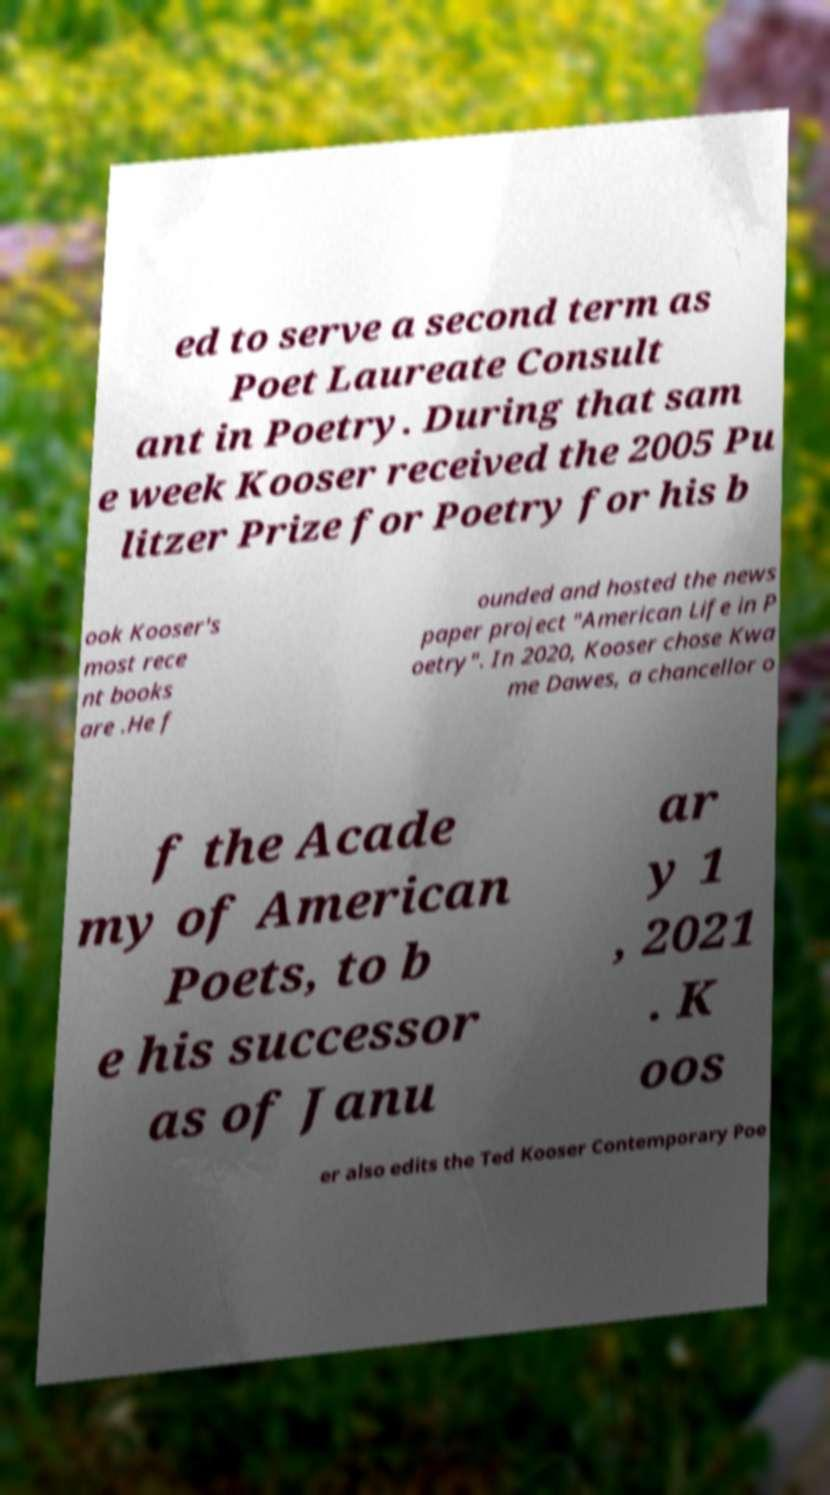Can you accurately transcribe the text from the provided image for me? ed to serve a second term as Poet Laureate Consult ant in Poetry. During that sam e week Kooser received the 2005 Pu litzer Prize for Poetry for his b ook Kooser's most rece nt books are .He f ounded and hosted the news paper project "American Life in P oetry". In 2020, Kooser chose Kwa me Dawes, a chancellor o f the Acade my of American Poets, to b e his successor as of Janu ar y 1 , 2021 . K oos er also edits the Ted Kooser Contemporary Poe 